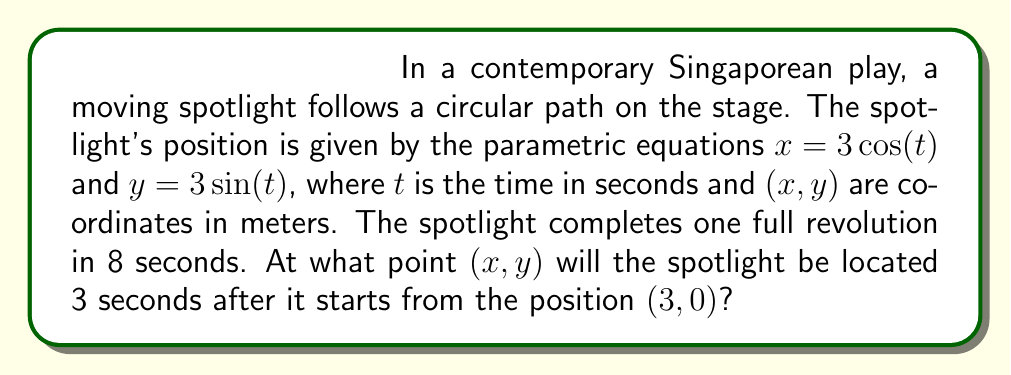What is the answer to this math problem? To solve this problem, we need to follow these steps:

1) First, we need to determine the angular velocity $\omega$ of the spotlight:
   $$\omega = \frac{2\pi}{T}$$
   where $T$ is the period (time for one full revolution).
   $$\omega = \frac{2\pi}{8} = \frac{\pi}{4} \text{ rad/s}$$

2) Now, we can write our parametric equations in terms of $\omega t$:
   $$x = 3\cos(\omega t) = 3\cos(\frac{\pi}{4}t)$$
   $$y = 3\sin(\omega t) = 3\sin(\frac{\pi}{4}t)$$

3) We want to find the position after 3 seconds, so we substitute $t=3$ into our equations:
   $$x = 3\cos(\frac{\pi}{4} \cdot 3) = 3\cos(\frac{3\pi}{4})$$
   $$y = 3\sin(\frac{\pi}{4} \cdot 3) = 3\sin(\frac{3\pi}{4})$$

4) Now we need to evaluate these trigonometric functions:
   $$\cos(\frac{3\pi}{4}) = -\frac{\sqrt{2}}{2}$$
   $$\sin(\frac{3\pi}{4}) = \frac{\sqrt{2}}{2}$$

5) Substituting these values back into our equations:
   $$x = 3 \cdot (-\frac{\sqrt{2}}{2}) = -\frac{3\sqrt{2}}{2}$$
   $$y = 3 \cdot (\frac{\sqrt{2}}{2}) = \frac{3\sqrt{2}}{2}$$

Therefore, after 3 seconds, the spotlight will be at the point $(-\frac{3\sqrt{2}}{2}, \frac{3\sqrt{2}}{2})$.
Answer: $(-\frac{3\sqrt{2}}{2}, \frac{3\sqrt{2}}{2})$ 